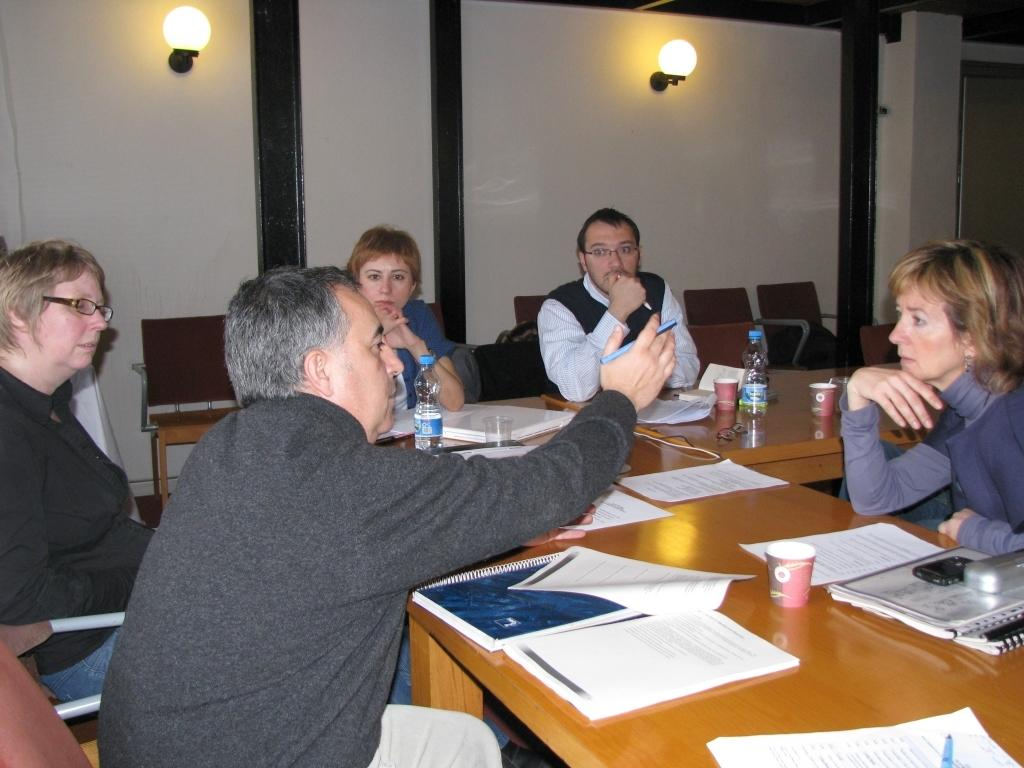What are the people in the image doing? The people in the image are sitting on chairs in the center of the image. What is located near the people in the image? There is a table in the image. What can be seen on the table? There are objects on the table. What is visible in the background of the image? There is a wall in the background of the image. What is attached to the wall? There are lights on the wall. What type of advice is being given by the mass in the image? There is no mass or advice present in the image; it features people sitting on chairs, a table, objects on the table, a wall, and lights on the wall. 